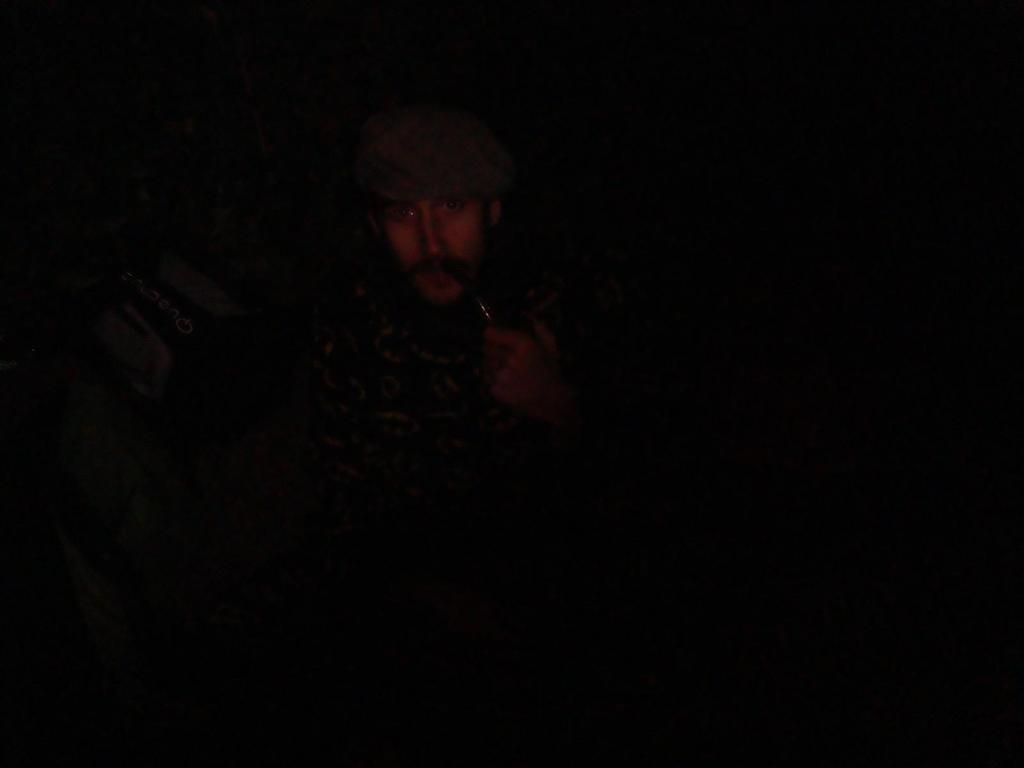What is the man in the image doing? The man is sitting in the image. What is the man wearing on his head? The man is wearing a cap. What activity is the man engaged in? The man is smoking. What can be seen on a surface in the image? There are objects on a surface in the image. What type of steel is the man using to knit a wool sweater in the image? There is no steel or wool sweater present in the image. The man is sitting and smoking, and there are objects on a surface, but no knitting or wool is mentioned. 